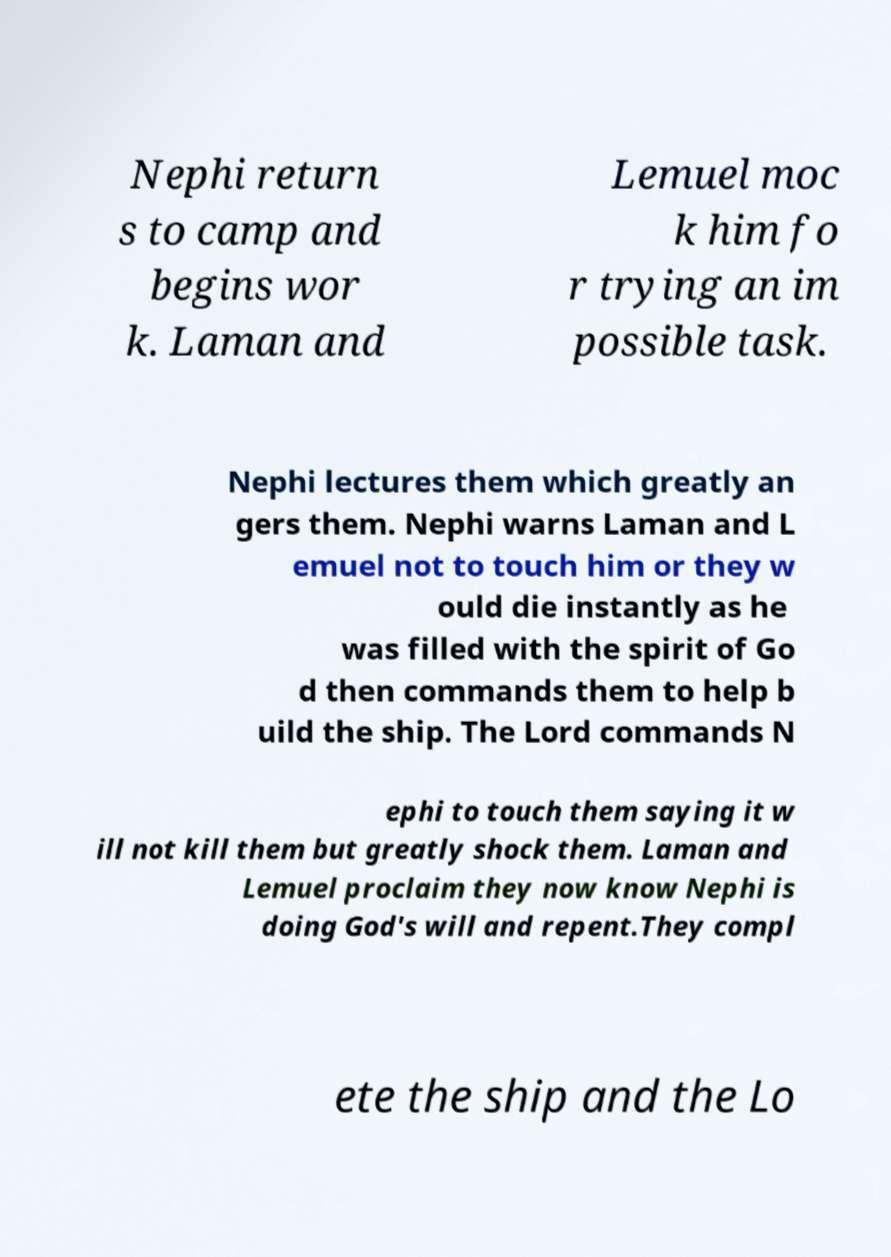What messages or text are displayed in this image? I need them in a readable, typed format. Nephi return s to camp and begins wor k. Laman and Lemuel moc k him fo r trying an im possible task. Nephi lectures them which greatly an gers them. Nephi warns Laman and L emuel not to touch him or they w ould die instantly as he was filled with the spirit of Go d then commands them to help b uild the ship. The Lord commands N ephi to touch them saying it w ill not kill them but greatly shock them. Laman and Lemuel proclaim they now know Nephi is doing God's will and repent.They compl ete the ship and the Lo 